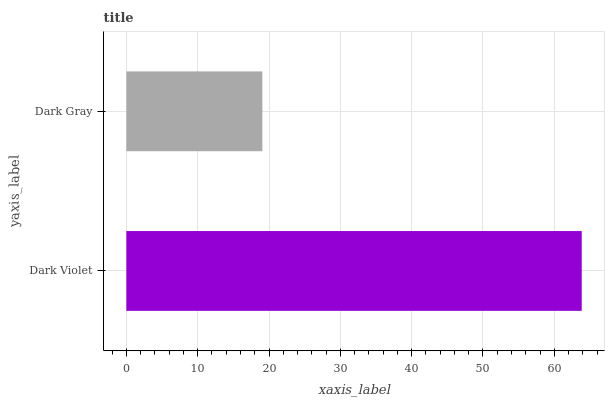Is Dark Gray the minimum?
Answer yes or no. Yes. Is Dark Violet the maximum?
Answer yes or no. Yes. Is Dark Gray the maximum?
Answer yes or no. No. Is Dark Violet greater than Dark Gray?
Answer yes or no. Yes. Is Dark Gray less than Dark Violet?
Answer yes or no. Yes. Is Dark Gray greater than Dark Violet?
Answer yes or no. No. Is Dark Violet less than Dark Gray?
Answer yes or no. No. Is Dark Violet the high median?
Answer yes or no. Yes. Is Dark Gray the low median?
Answer yes or no. Yes. Is Dark Gray the high median?
Answer yes or no. No. Is Dark Violet the low median?
Answer yes or no. No. 